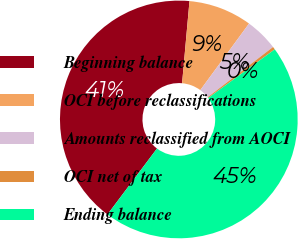Convert chart to OTSL. <chart><loc_0><loc_0><loc_500><loc_500><pie_chart><fcel>Beginning balance<fcel>OCI before reclassifications<fcel>Amounts reclassified from AOCI<fcel>OCI net of tax<fcel>Ending balance<nl><fcel>41.18%<fcel>8.63%<fcel>4.51%<fcel>0.39%<fcel>45.29%<nl></chart> 